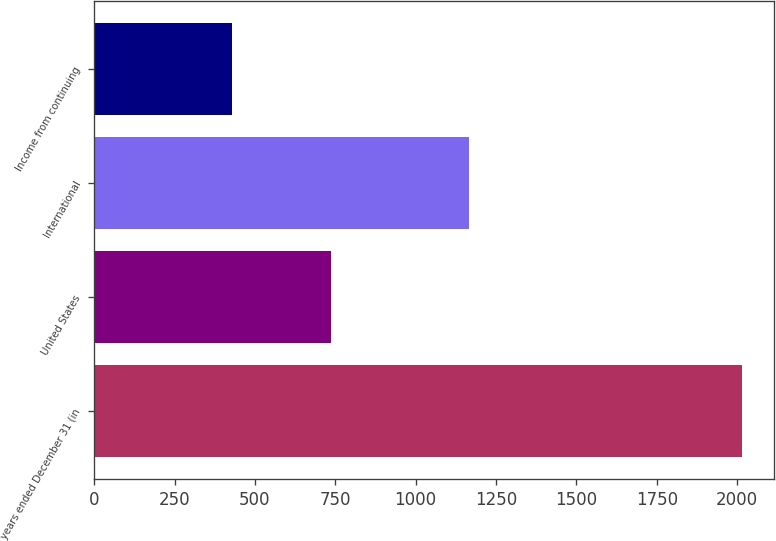Convert chart. <chart><loc_0><loc_0><loc_500><loc_500><bar_chart><fcel>years ended December 31 (in<fcel>United States<fcel>International<fcel>Income from continuing<nl><fcel>2015<fcel>738<fcel>1166<fcel>428<nl></chart> 